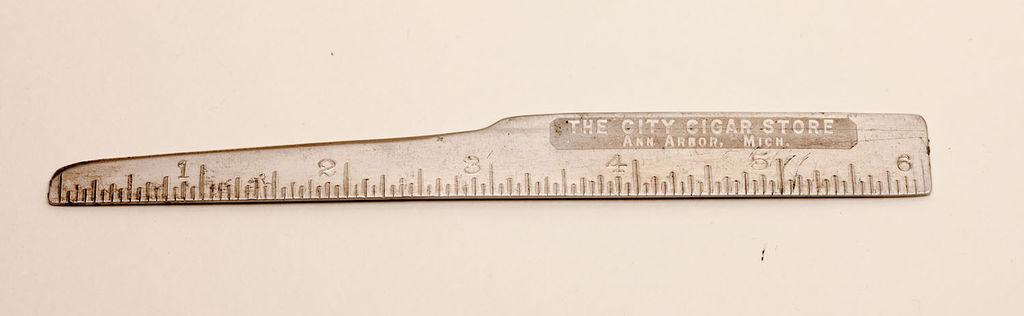What object can be seen in the image? There is a scale in the image. What color is the background of the image? The background of the image is white. How many worms are crawling on the tray in the image? There are no worms or trays present in the image; it only features a scale with a white background. 